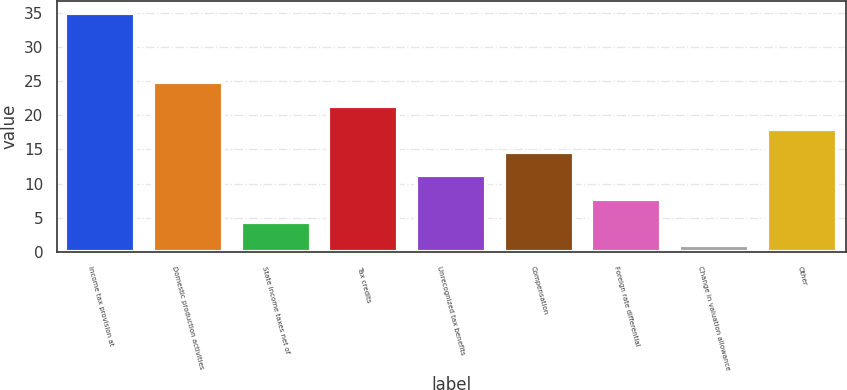Convert chart to OTSL. <chart><loc_0><loc_0><loc_500><loc_500><bar_chart><fcel>Income tax provision at<fcel>Domestic production activities<fcel>State income taxes net of<fcel>Tax credits<fcel>Unrecognized tax benefits<fcel>Compensation<fcel>Foreign rate differential<fcel>Change in valuation allowance<fcel>Other<nl><fcel>35<fcel>24.8<fcel>4.4<fcel>21.4<fcel>11.2<fcel>14.6<fcel>7.8<fcel>1<fcel>18<nl></chart> 